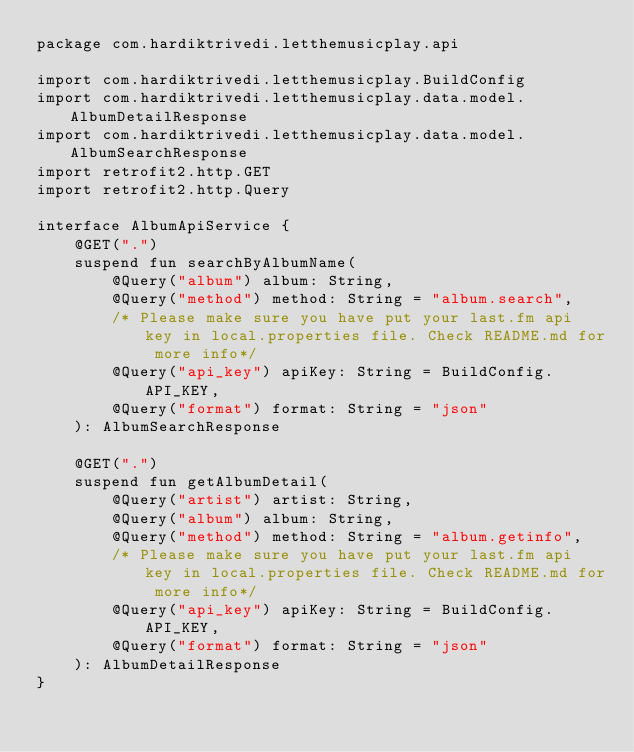<code> <loc_0><loc_0><loc_500><loc_500><_Kotlin_>package com.hardiktrivedi.letthemusicplay.api

import com.hardiktrivedi.letthemusicplay.BuildConfig
import com.hardiktrivedi.letthemusicplay.data.model.AlbumDetailResponse
import com.hardiktrivedi.letthemusicplay.data.model.AlbumSearchResponse
import retrofit2.http.GET
import retrofit2.http.Query

interface AlbumApiService {
    @GET(".")
    suspend fun searchByAlbumName(
        @Query("album") album: String,
        @Query("method") method: String = "album.search",
        /* Please make sure you have put your last.fm api key in local.properties file. Check README.md for more info*/
        @Query("api_key") apiKey: String = BuildConfig.API_KEY,
        @Query("format") format: String = "json"
    ): AlbumSearchResponse

    @GET(".")
    suspend fun getAlbumDetail(
        @Query("artist") artist: String,
        @Query("album") album: String,
        @Query("method") method: String = "album.getinfo",
        /* Please make sure you have put your last.fm api key in local.properties file. Check README.md for more info*/
        @Query("api_key") apiKey: String = BuildConfig.API_KEY,
        @Query("format") format: String = "json"
    ): AlbumDetailResponse
}</code> 